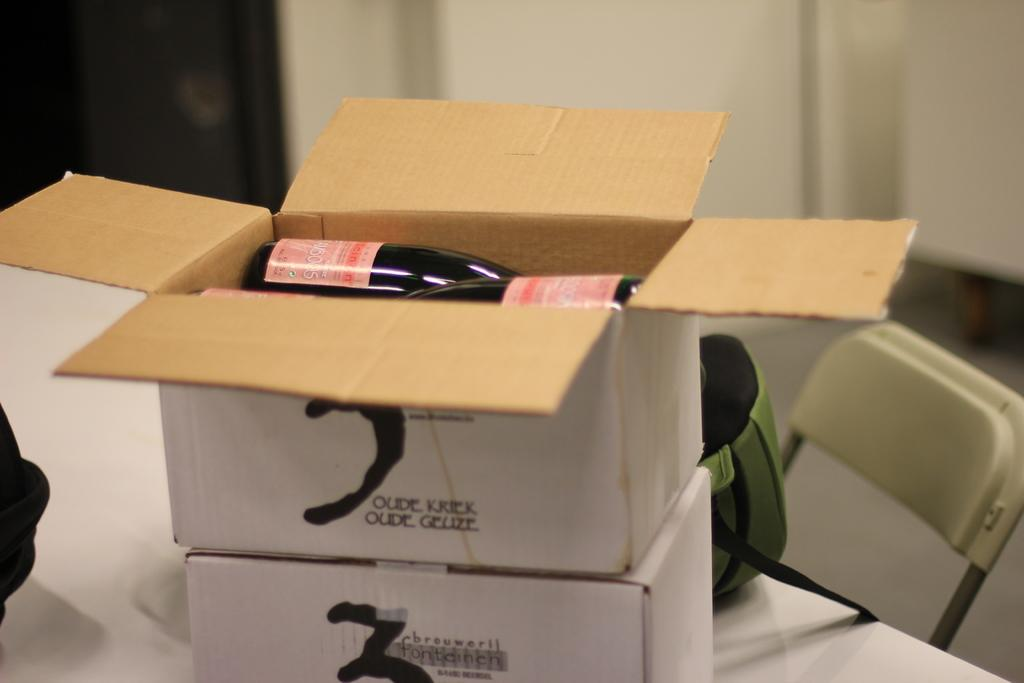<image>
Share a concise interpretation of the image provided. Two boxes stacked on top of each other and the top one reads Oude Kriek Oude Geuze 